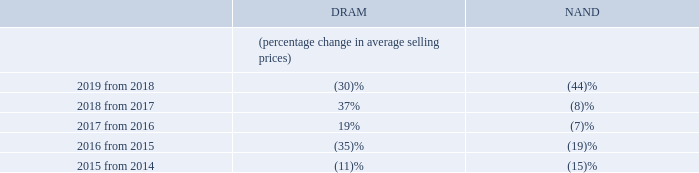Volatility in average selling prices for our semiconductor memory and storage products may adversely affect our business.
We have experienced significant volatility in our average selling prices, including dramatic declines as noted in the table below, and may continue to experience such volatility in the future. In some prior periods, average selling prices for our products have been below our manufacturing costs and we may experience such circumstances in the future. Average selling prices for our products that decline faster than our costs could have a material adverse effect on our business, results of operations, or financial condition.
What was the effect on the company when the average selling prices for the products decline faster than the costs? A material adverse effect on our business, results of operations, or financial condition. What is the percentage change in average selling price of DRAM from 2016 to 2017? 19%. 	 What is the percentage change in average selling price of NAND from 2018 to 2019? (44)%. What is the difference between percentage change in average selling prices of DRAM and NAND in 2019 from 2018?
Answer scale should be: percent. 44 - 30 
Answer: 14. What is the ratio of percentage change in average selling prices of DRAM in '2017 from 2016' to '2018 from 2017'? 19/37 
Answer: 0.51. What is the highest percentage increase in average selling prices of DRAM from 2015 to 2019?
Answer scale should be: percent. 37% > 19% > -11% > -30% > -35% 37% is the highest percentage change
Answer: 37. 